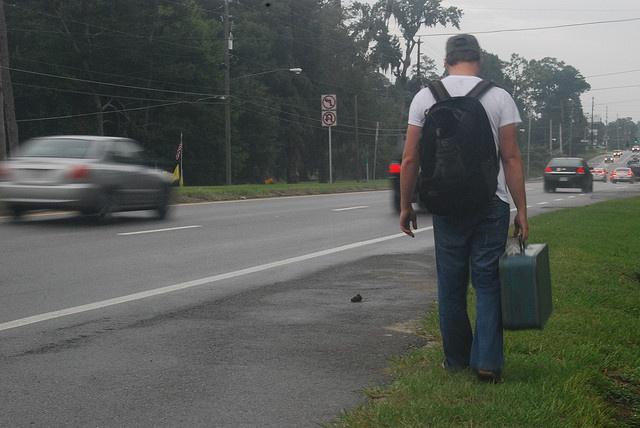Describe the objects in this image and their specific colors. I can see people in black, gray, darkblue, and darkgray tones, car in black, gray, and darkgray tones, backpack in black and gray tones, suitcase in black, gray, purple, and darkgray tones, and car in black, gray, and purple tones in this image. 